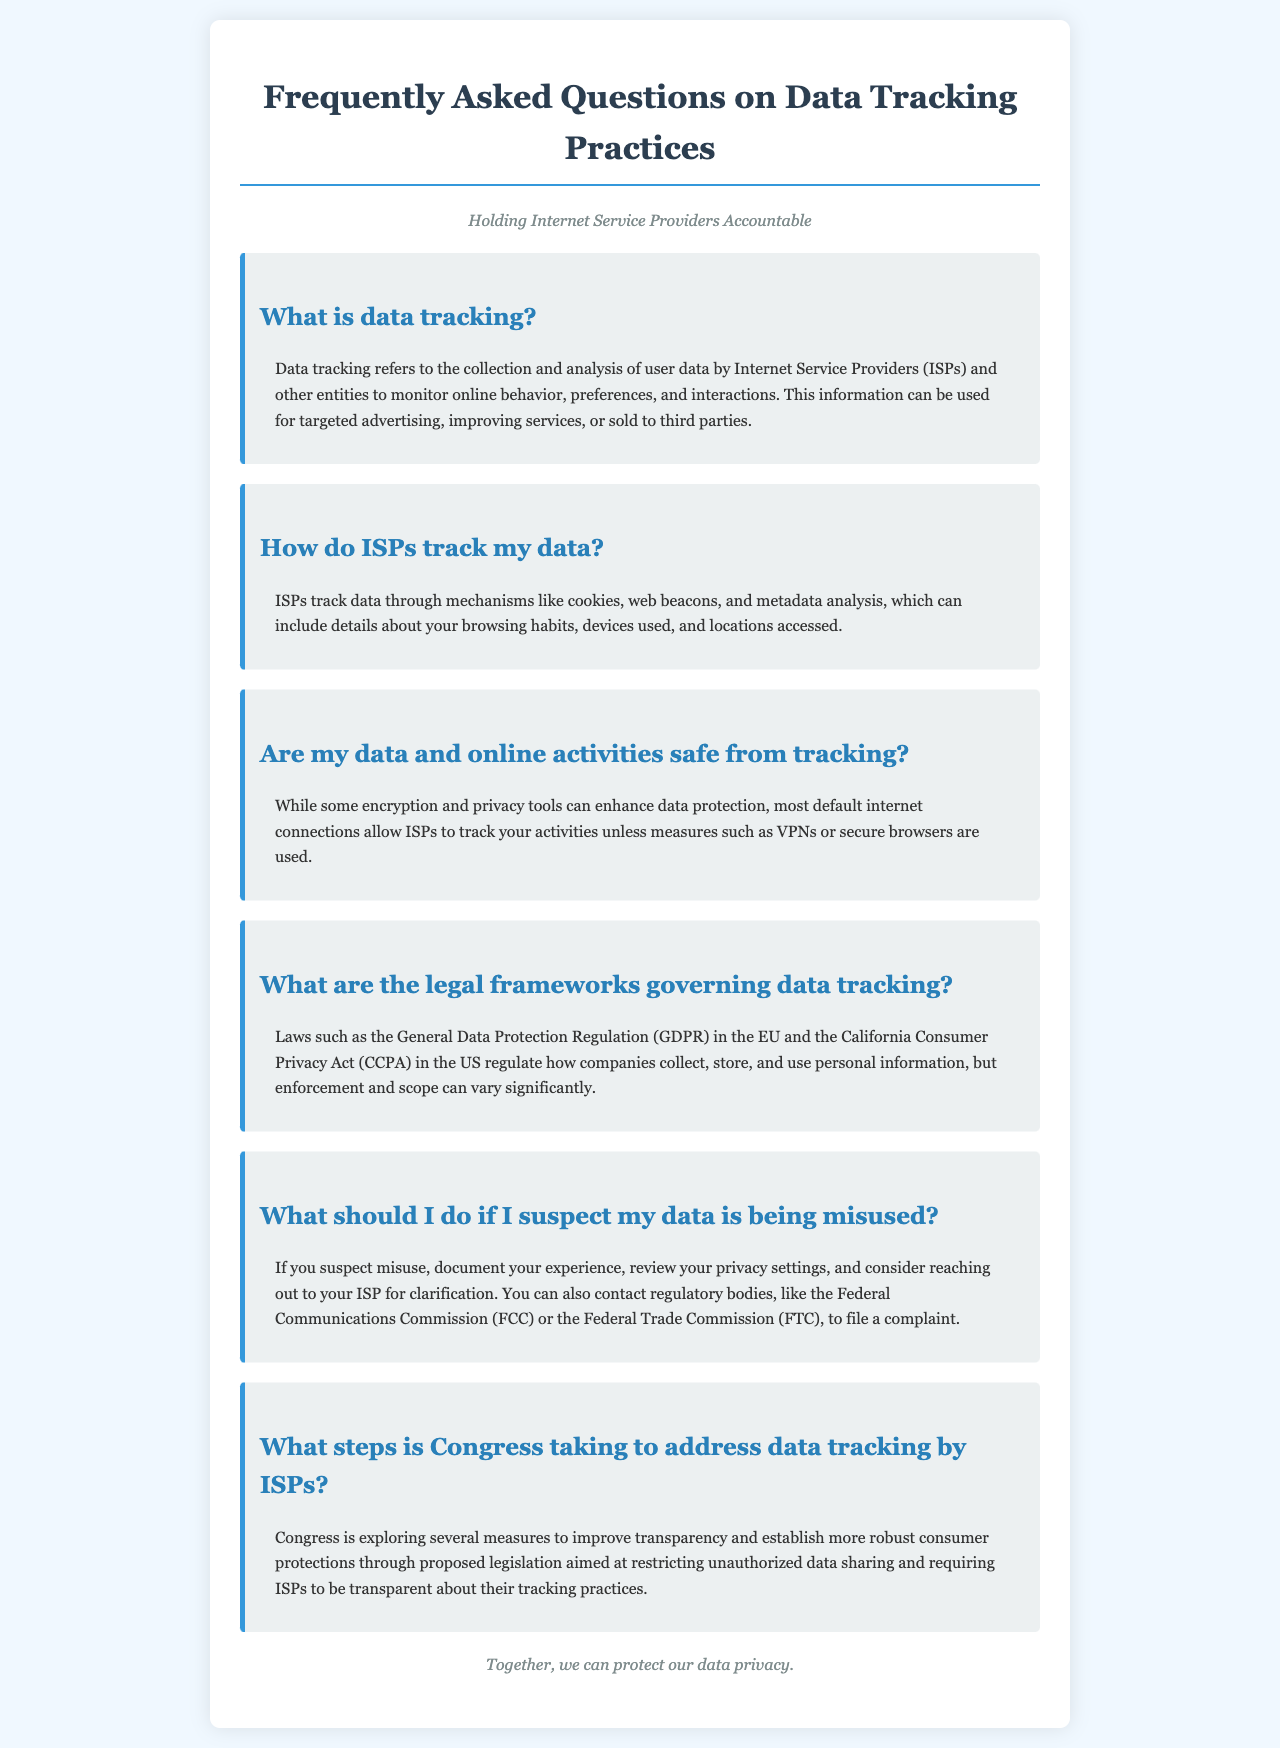What is data tracking? The definition of data tracking is provided, explaining its purpose in monitoring user behavior.
Answer: Collection and analysis of user data How do ISPs track data? The document lists specific methods used by ISPs to monitor user activities.
Answer: Through cookies, web beacons, and metadata analysis Are data and online activities safe from tracking? The answer addresses the effectiveness of encryption and privacy tools related to data safety.
Answer: No, unless measures such as VPNs or secure browsers are used What legal frameworks govern data tracking? The FAQ mentions specific laws that regulate data collection and usage.
Answer: GDPR and CCPA What should I do if I suspect data misuse? The document outlines steps to take if misuse is suspected.
Answer: Document your experience and contact your ISP What steps is Congress taking to address data tracking? The answer summarizes Congressional actions to improve data transparency and protection.
Answer: Proposed legislation aimed at restricting unauthorized data sharing 